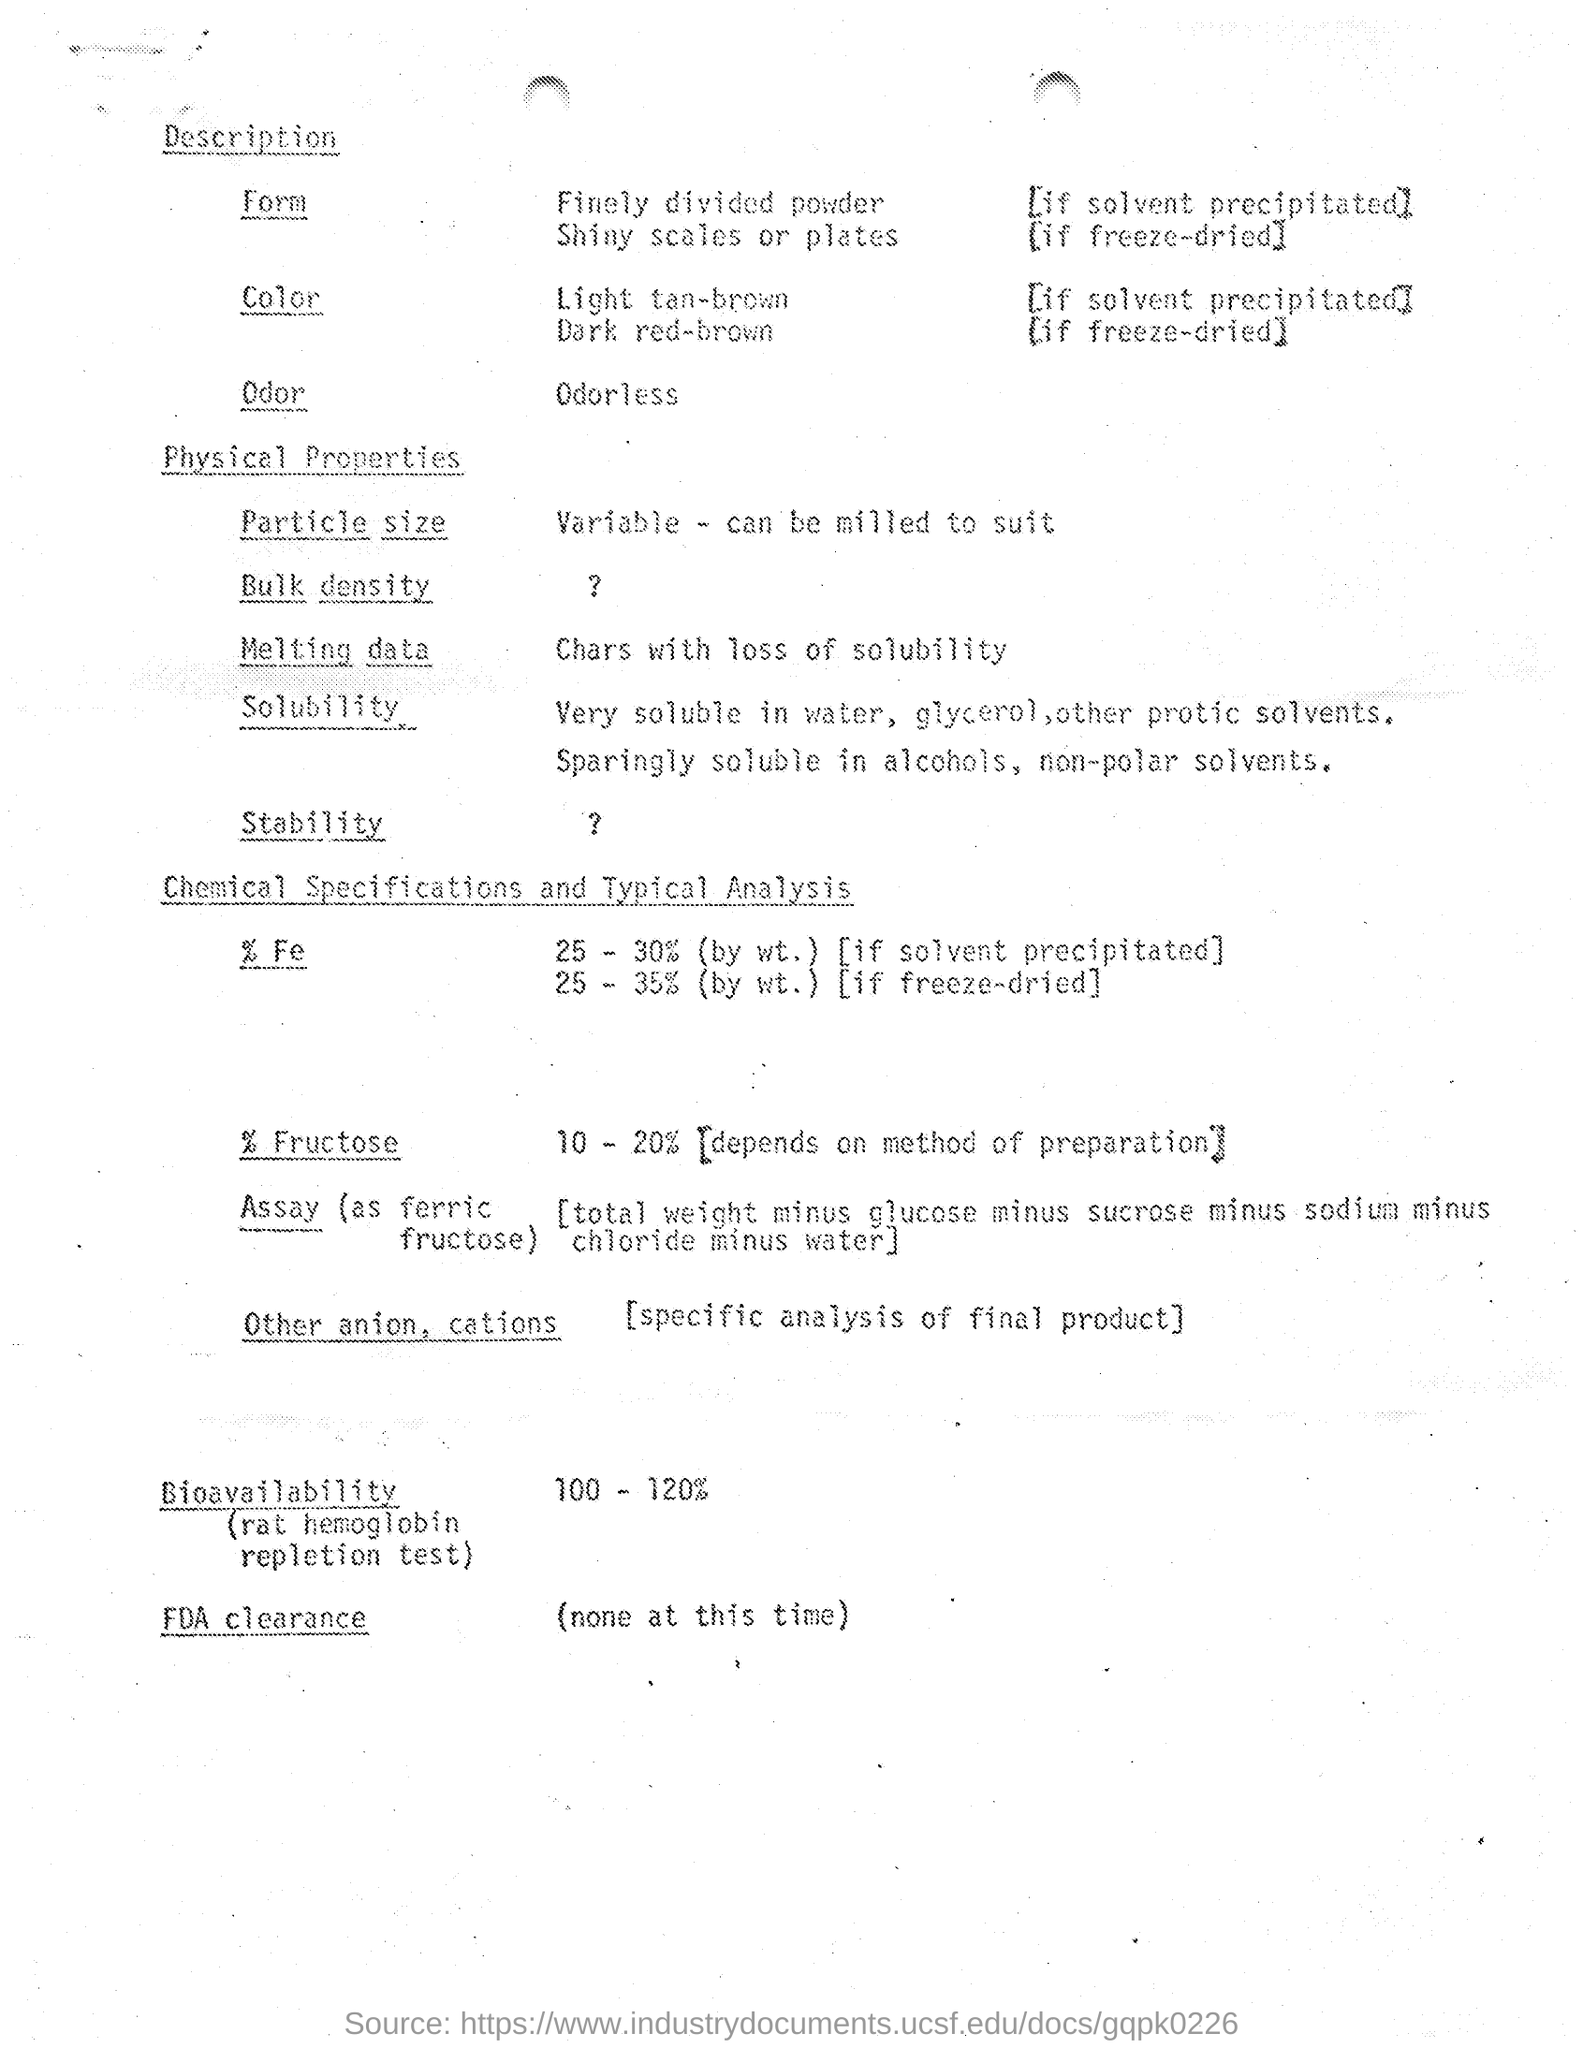Point out several critical features in this image. The color of freeze-dried material is dark red-brown. If a solvent is used to precipitate the color, it results in a light tan-brown color. The substance is odorless. The solvent will precipitate the substance in the form of a finely divided powder. Frogs have shiny scales or plates that freeze-dry in a particular form. 